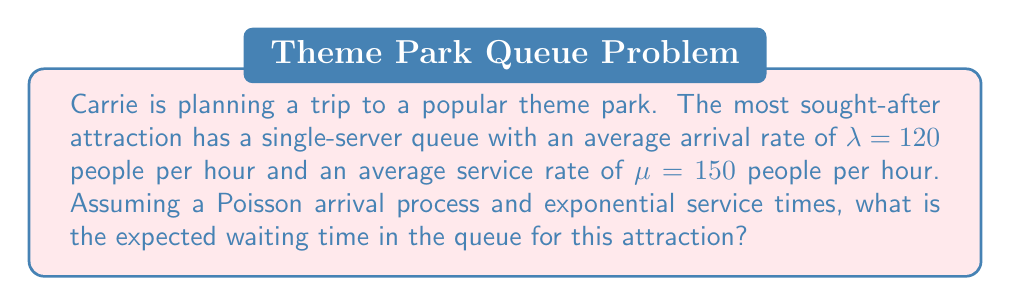Could you help me with this problem? To solve this problem, we'll use the M/M/1 queuing model and follow these steps:

1) First, we need to calculate the utilization factor $\rho$:
   $\rho = \frac{\lambda}{\mu} = \frac{120}{150} = 0.8$

2) The expected number of customers in the queue (excluding the one being served) is given by:
   $L_q = \frac{\rho^2}{1-\rho} = \frac{0.8^2}{1-0.8} = \frac{0.64}{0.2} = 3.2$

3) Using Little's Law, we can calculate the expected waiting time in the queue:
   $W_q = \frac{L_q}{\lambda}$

4) Substituting the values:
   $W_q = \frac{3.2}{120} = \frac{1}{37.5}$ hours

5) Convert this to minutes:
   $W_q = \frac{1}{37.5} \times 60 = 1.6$ minutes

Therefore, the expected waiting time in the queue is approximately 1.6 minutes.
Answer: 1.6 minutes 